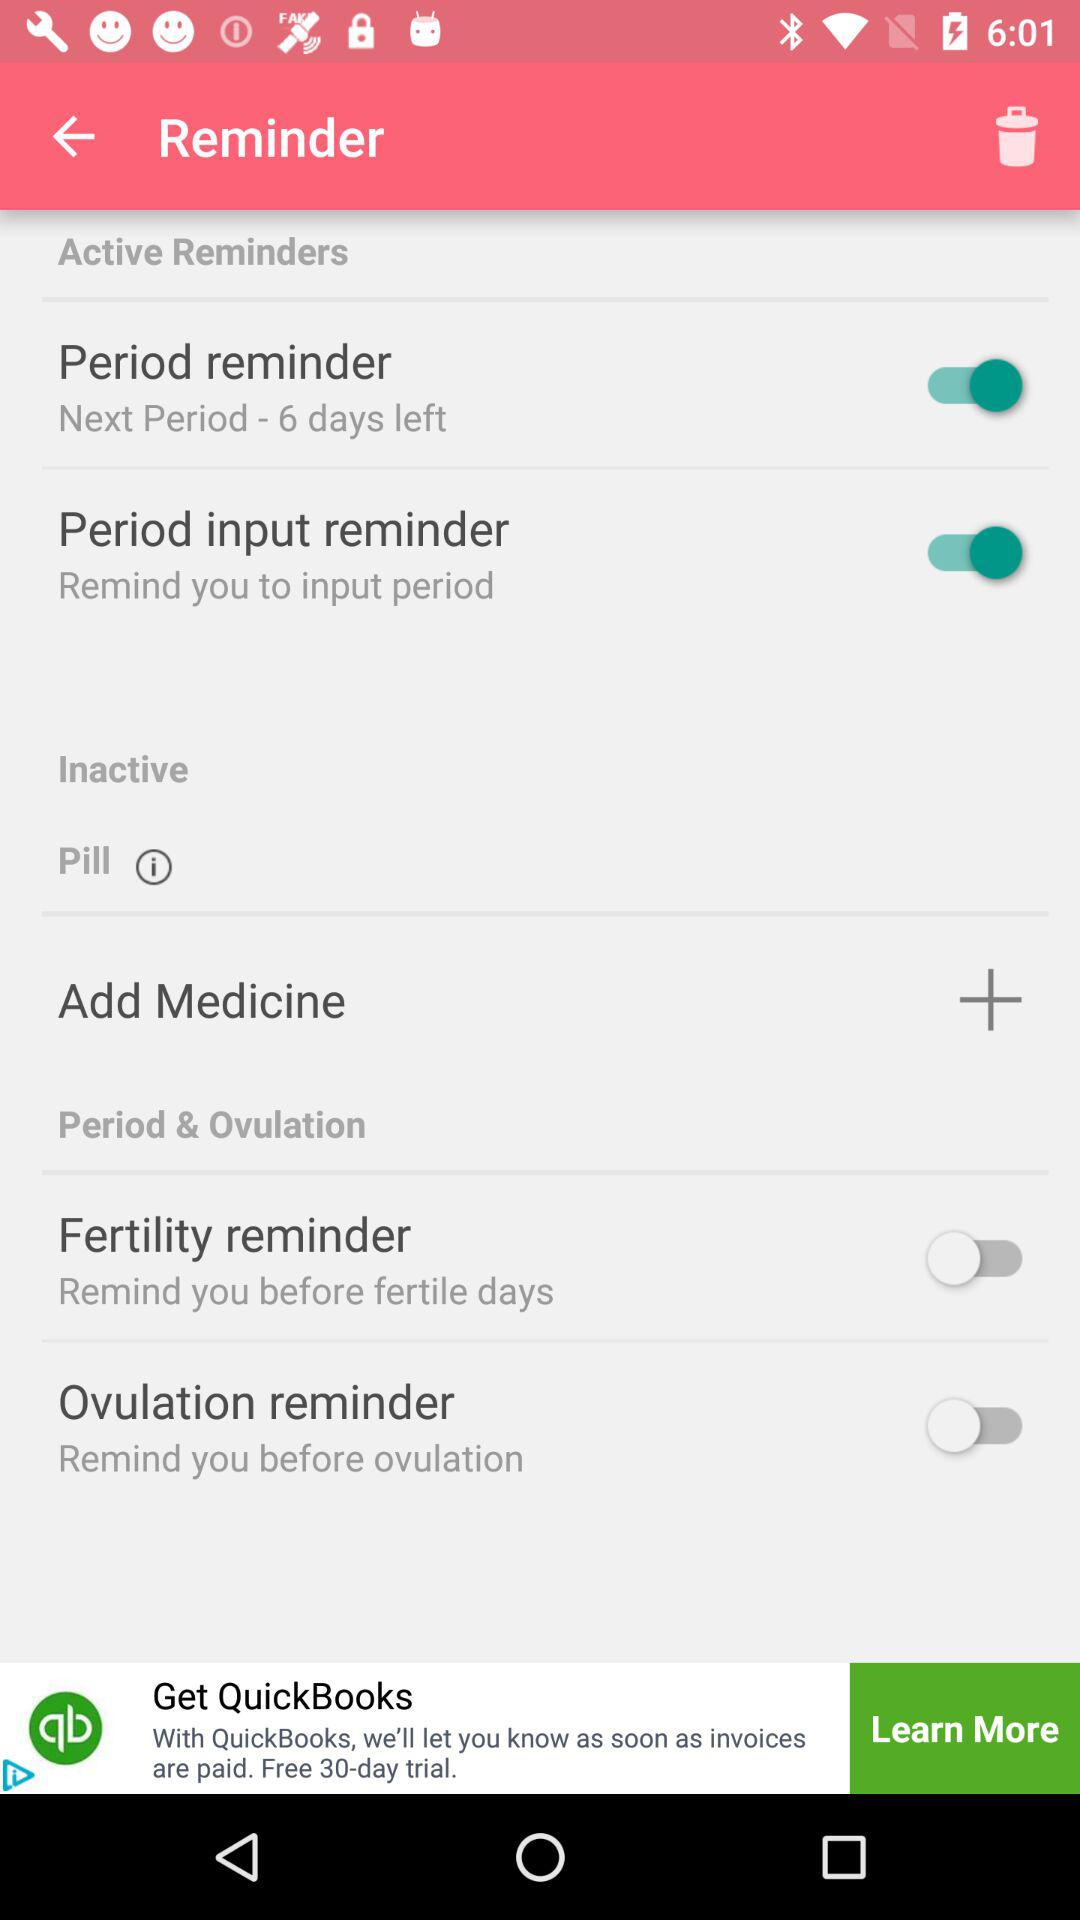What is the status of "Period reminder"? The status is "on". 